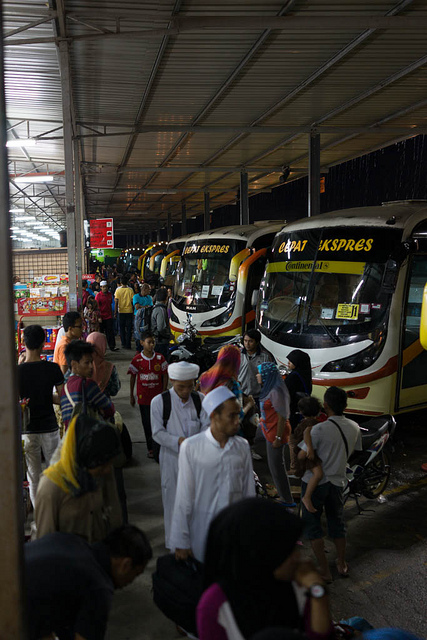Identify the text displayed in this image. EXPRESS CEPAT KSPRES 